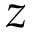Convert formula to latex. <formula><loc_0><loc_0><loc_500><loc_500>z</formula> 